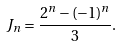<formula> <loc_0><loc_0><loc_500><loc_500>J _ { n } = \frac { 2 ^ { n } - ( - 1 ) ^ { n } } { 3 } .</formula> 